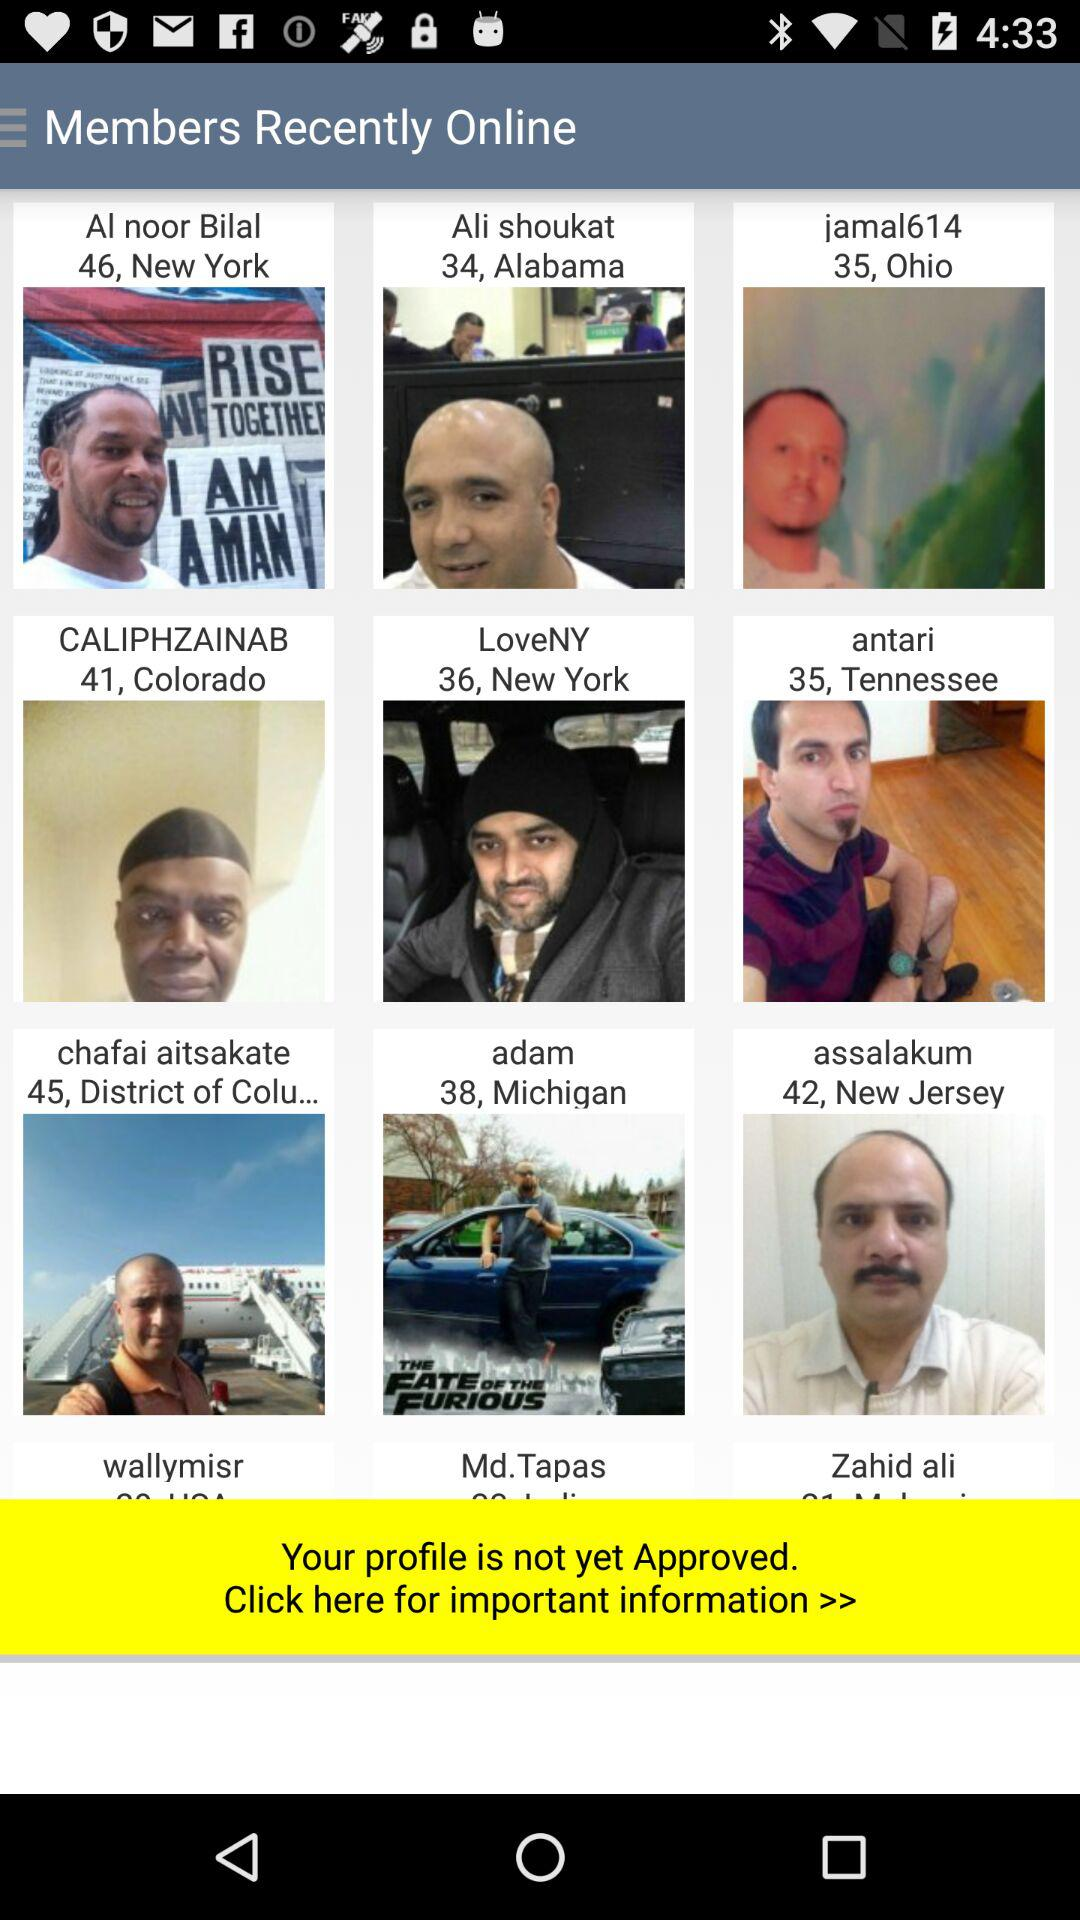Who belongs to Colorado? The person who belongs to Colorado is Caliphzainab. 